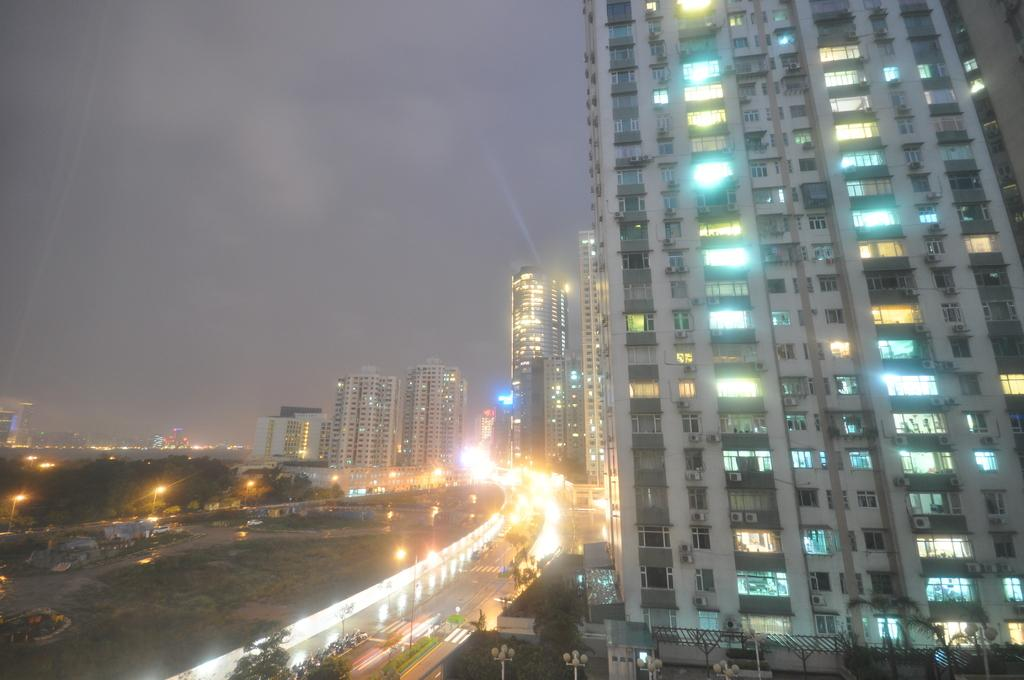What is located in the center of the image? In the center of the image, there are buildings, lights, windows, trees, poles, vehicles, plants, grass, and tents. What type of structures are present in the image? The image features buildings and tents. What can be seen on the ground in the center of the image? There is a road, grass, and plants visible on the ground in the center of the image. What is visible in the background of the image? The sky, clouds, and possibly more buildings can be seen in the background of the image. Where are your dad and friends in the image? There is no mention of a dad or friends in the image. How can you get the attention of the people in the image? The image does not depict any people, so it is not possible to get their attention. 